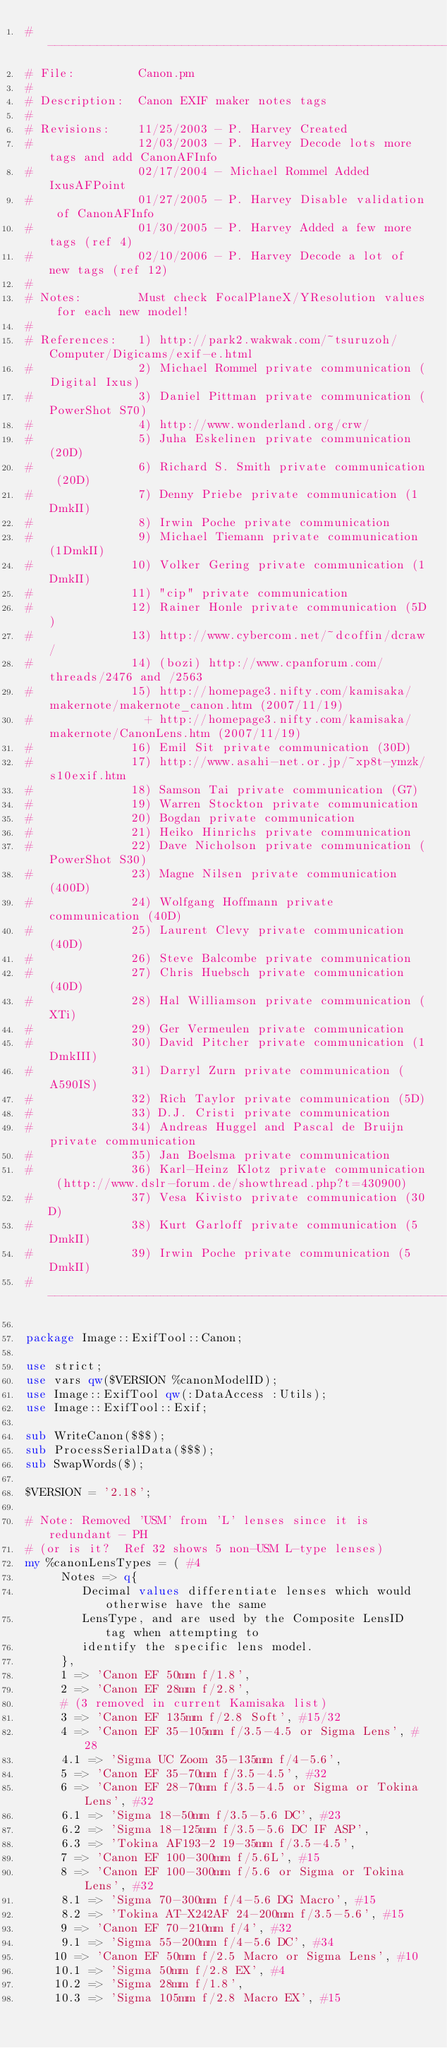Convert code to text. <code><loc_0><loc_0><loc_500><loc_500><_Perl_>#------------------------------------------------------------------------------
# File:         Canon.pm
#
# Description:  Canon EXIF maker notes tags
#
# Revisions:    11/25/2003 - P. Harvey Created
#               12/03/2003 - P. Harvey Decode lots more tags and add CanonAFInfo
#               02/17/2004 - Michael Rommel Added IxusAFPoint
#               01/27/2005 - P. Harvey Disable validation of CanonAFInfo
#               01/30/2005 - P. Harvey Added a few more tags (ref 4)
#               02/10/2006 - P. Harvey Decode a lot of new tags (ref 12)
#
# Notes:        Must check FocalPlaneX/YResolution values for each new model!
#
# References:   1) http://park2.wakwak.com/~tsuruzoh/Computer/Digicams/exif-e.html
#               2) Michael Rommel private communication (Digital Ixus)
#               3) Daniel Pittman private communication (PowerShot S70)
#               4) http://www.wonderland.org/crw/
#               5) Juha Eskelinen private communication (20D)
#               6) Richard S. Smith private communication (20D)
#               7) Denny Priebe private communication (1DmkII)
#               8) Irwin Poche private communication
#               9) Michael Tiemann private communication (1DmkII)
#              10) Volker Gering private communication (1DmkII)
#              11) "cip" private communication
#              12) Rainer Honle private communication (5D)
#              13) http://www.cybercom.net/~dcoffin/dcraw/
#              14) (bozi) http://www.cpanforum.com/threads/2476 and /2563
#              15) http://homepage3.nifty.com/kamisaka/makernote/makernote_canon.htm (2007/11/19)
#                + http://homepage3.nifty.com/kamisaka/makernote/CanonLens.htm (2007/11/19)
#              16) Emil Sit private communication (30D)
#              17) http://www.asahi-net.or.jp/~xp8t-ymzk/s10exif.htm
#              18) Samson Tai private communication (G7)
#              19) Warren Stockton private communication
#              20) Bogdan private communication
#              21) Heiko Hinrichs private communication
#              22) Dave Nicholson private communication (PowerShot S30)
#              23) Magne Nilsen private communication (400D)
#              24) Wolfgang Hoffmann private communication (40D)
#              25) Laurent Clevy private communication (40D)
#              26) Steve Balcombe private communication
#              27) Chris Huebsch private communication (40D)
#              28) Hal Williamson private communication (XTi)
#              29) Ger Vermeulen private communication
#              30) David Pitcher private communication (1DmkIII)
#              31) Darryl Zurn private communication (A590IS)
#              32) Rich Taylor private communication (5D)
#              33) D.J. Cristi private communication
#              34) Andreas Huggel and Pascal de Bruijn private communication
#              35) Jan Boelsma private communication
#              36) Karl-Heinz Klotz private communication (http://www.dslr-forum.de/showthread.php?t=430900)
#              37) Vesa Kivisto private communication (30D)
#              38) Kurt Garloff private communication (5DmkII)
#              39) Irwin Poche private communication (5DmkII)
#------------------------------------------------------------------------------

package Image::ExifTool::Canon;

use strict;
use vars qw($VERSION %canonModelID);
use Image::ExifTool qw(:DataAccess :Utils);
use Image::ExifTool::Exif;

sub WriteCanon($$$);
sub ProcessSerialData($$$);
sub SwapWords($);

$VERSION = '2.18';

# Note: Removed 'USM' from 'L' lenses since it is redundant - PH
# (or is it?  Ref 32 shows 5 non-USM L-type lenses)
my %canonLensTypes = ( #4
     Notes => q{
        Decimal values differentiate lenses which would otherwise have the same
        LensType, and are used by the Composite LensID tag when attempting to
        identify the specific lens model.
     },
     1 => 'Canon EF 50mm f/1.8',
     2 => 'Canon EF 28mm f/2.8',
     # (3 removed in current Kamisaka list)
     3 => 'Canon EF 135mm f/2.8 Soft', #15/32
     4 => 'Canon EF 35-105mm f/3.5-4.5 or Sigma Lens', #28
     4.1 => 'Sigma UC Zoom 35-135mm f/4-5.6',
     5 => 'Canon EF 35-70mm f/3.5-4.5', #32
     6 => 'Canon EF 28-70mm f/3.5-4.5 or Sigma or Tokina Lens', #32
     6.1 => 'Sigma 18-50mm f/3.5-5.6 DC', #23
     6.2 => 'Sigma 18-125mm f/3.5-5.6 DC IF ASP',
     6.3 => 'Tokina AF193-2 19-35mm f/3.5-4.5',
     7 => 'Canon EF 100-300mm f/5.6L', #15
     8 => 'Canon EF 100-300mm f/5.6 or Sigma or Tokina Lens', #32
     8.1 => 'Sigma 70-300mm f/4-5.6 DG Macro', #15
     8.2 => 'Tokina AT-X242AF 24-200mm f/3.5-5.6', #15
     9 => 'Canon EF 70-210mm f/4', #32
     9.1 => 'Sigma 55-200mm f/4-5.6 DC', #34
    10 => 'Canon EF 50mm f/2.5 Macro or Sigma Lens', #10
    10.1 => 'Sigma 50mm f/2.8 EX', #4
    10.2 => 'Sigma 28mm f/1.8',
    10.3 => 'Sigma 105mm f/2.8 Macro EX', #15</code> 